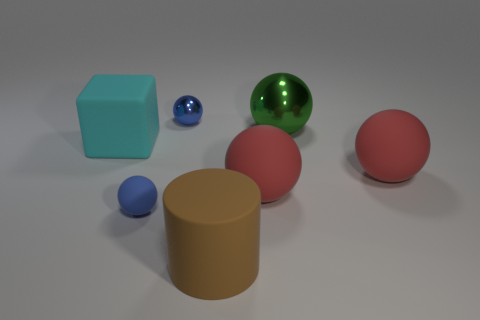Subtract all green balls. How many balls are left? 4 Subtract all blue metallic balls. How many balls are left? 4 Subtract all cyan balls. Subtract all yellow cylinders. How many balls are left? 5 Add 2 blue matte spheres. How many objects exist? 9 Subtract all cylinders. How many objects are left? 6 Add 5 big brown cylinders. How many big brown cylinders exist? 6 Subtract 0 gray spheres. How many objects are left? 7 Subtract all big cyan metallic things. Subtract all small blue matte spheres. How many objects are left? 6 Add 4 large red rubber balls. How many large red rubber balls are left? 6 